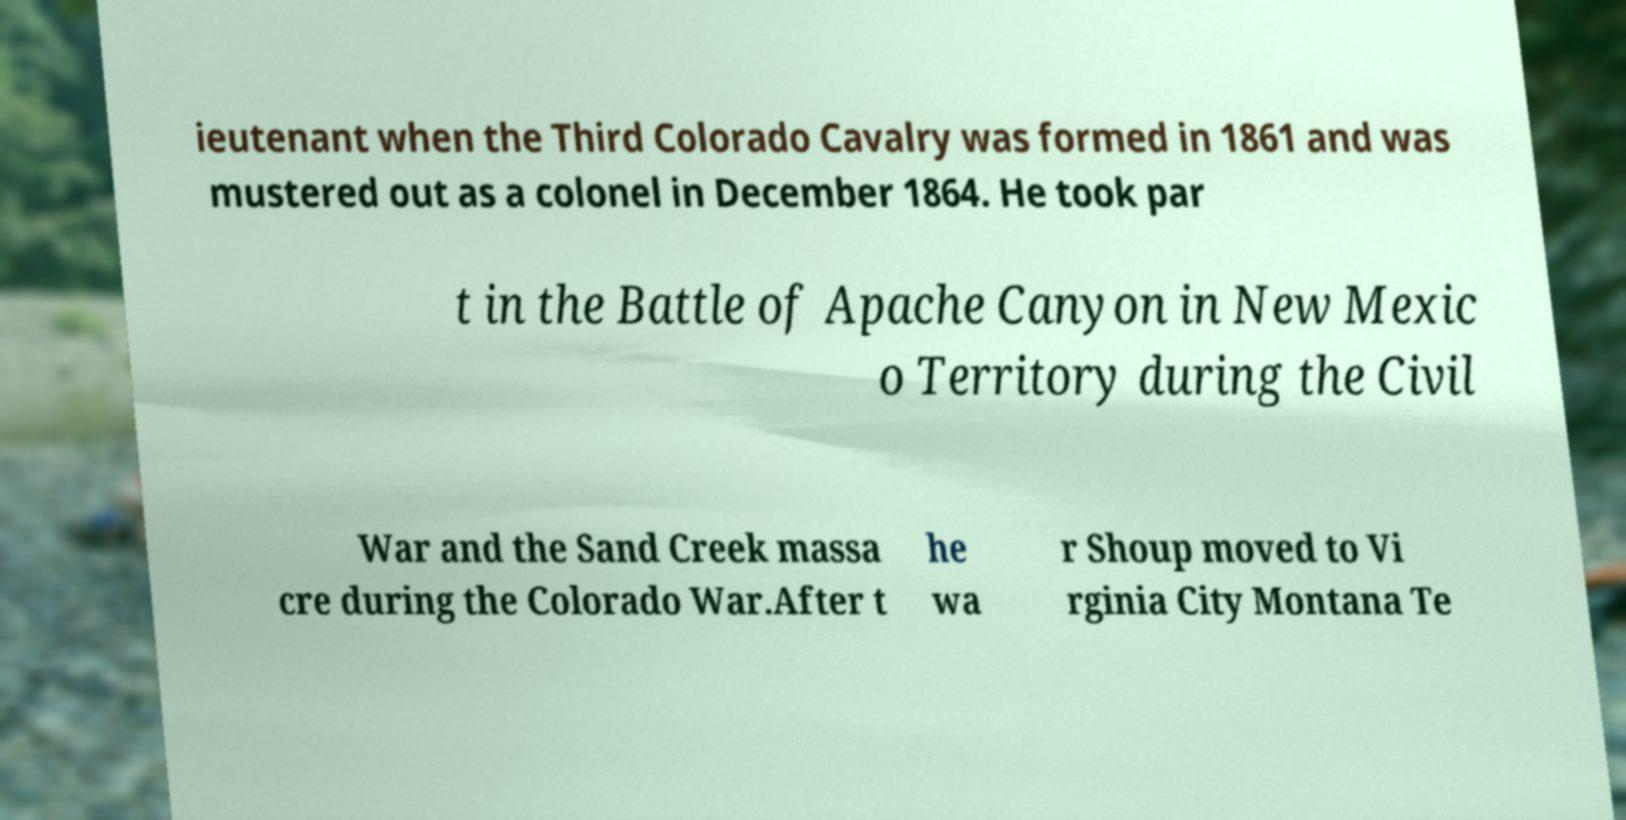There's text embedded in this image that I need extracted. Can you transcribe it verbatim? ieutenant when the Third Colorado Cavalry was formed in 1861 and was mustered out as a colonel in December 1864. He took par t in the Battle of Apache Canyon in New Mexic o Territory during the Civil War and the Sand Creek massa cre during the Colorado War.After t he wa r Shoup moved to Vi rginia City Montana Te 